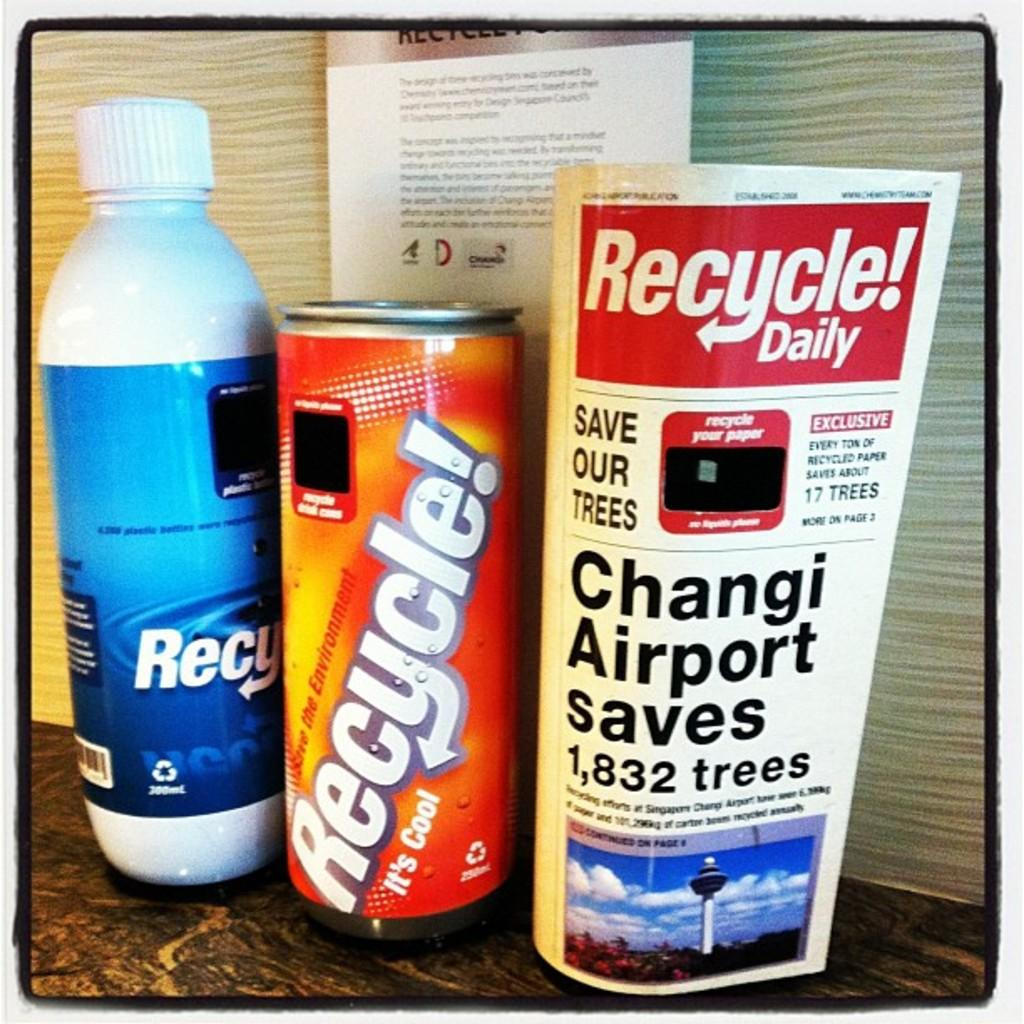<image>
Summarize the visual content of the image. A bottle, a can and a sachet all have recycle written on them 